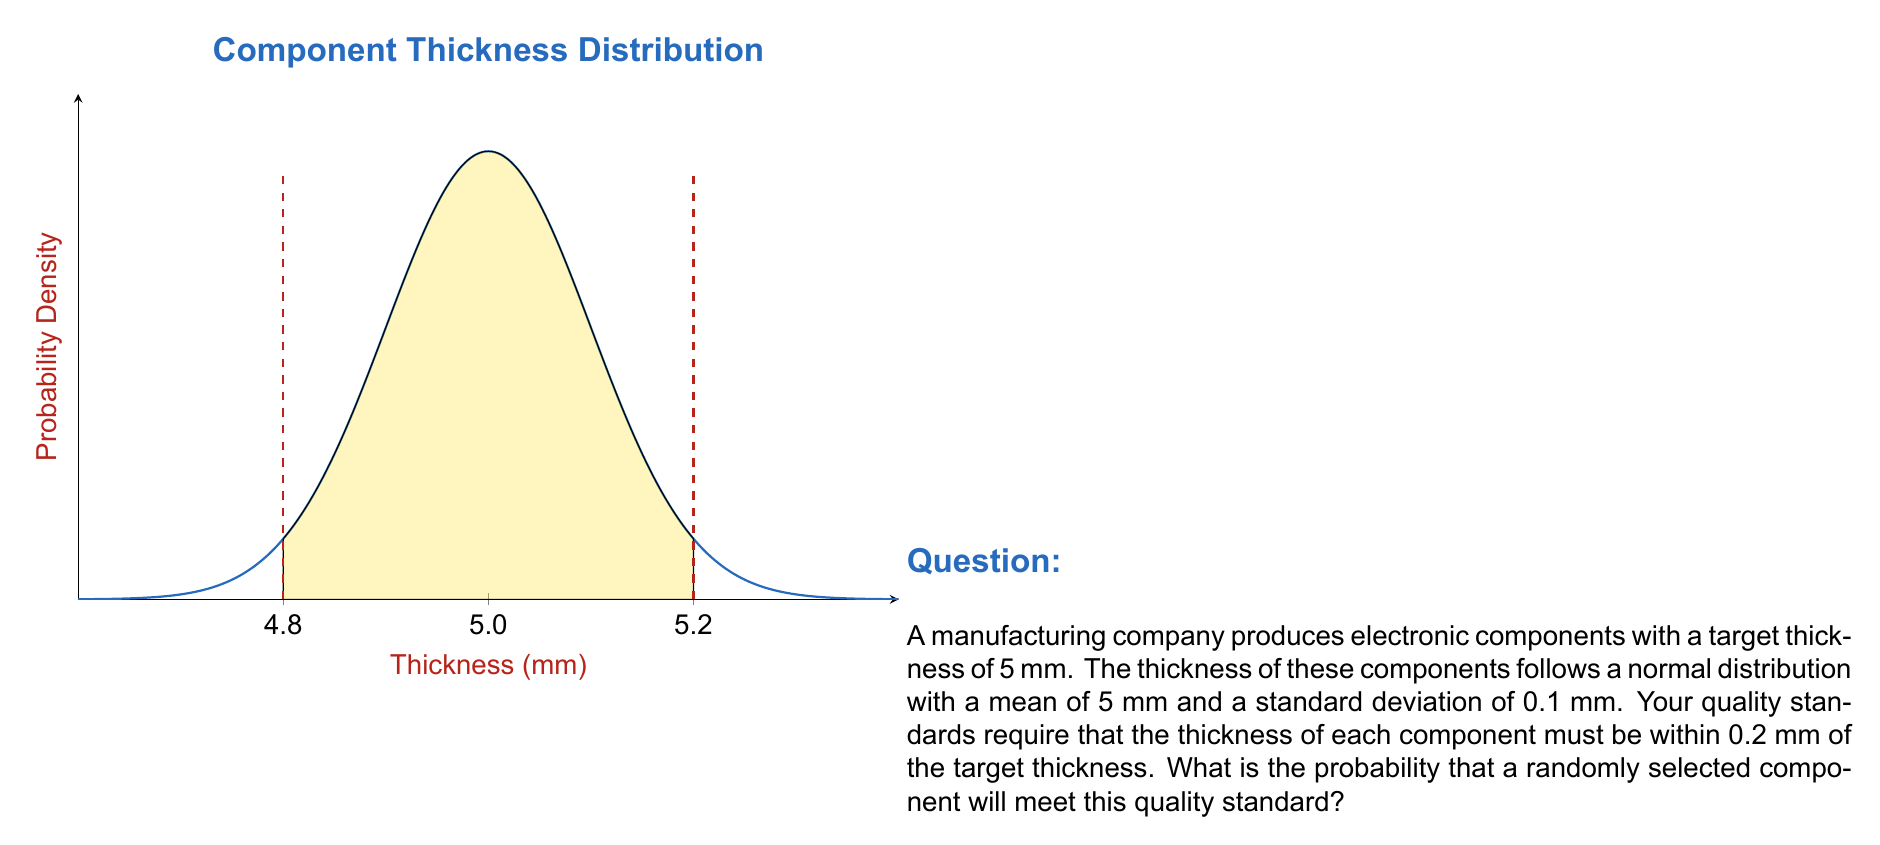Give your solution to this math problem. Let's approach this step-by-step:

1) We are given that the thickness follows a normal distribution with:
   Mean (μ) = 5 mm
   Standard deviation (σ) = 0.1 mm

2) The quality standard requires the thickness to be within 0.2 mm of the target (5 mm). This means the acceptable range is:
   Lower bound: 5 - 0.2 = 4.8 mm
   Upper bound: 5 + 0.2 = 5.2 mm

3) To find the probability, we need to calculate the z-scores for both bounds:

   For lower bound: $z_1 = \frac{4.8 - 5}{0.1} = -2$
   For upper bound: $z_2 = \frac{5.2 - 5}{0.1} = 2$

4) The probability of a component meeting the quality standard is the area under the normal curve between these two z-scores.

5) Using the standard normal distribution table or a calculator, we can find:
   $P(Z \leq 2) = 0.9772$
   $P(Z \leq -2) = 0.0228$

6) The probability we're looking for is:
   $P(-2 \leq Z \leq 2) = P(Z \leq 2) - P(Z \leq -2) = 0.9772 - 0.0228 = 0.9544$

Therefore, the probability that a randomly selected component will meet the quality standard is 0.9544 or about 95.44%.
Answer: 0.9544 (or 95.44%) 